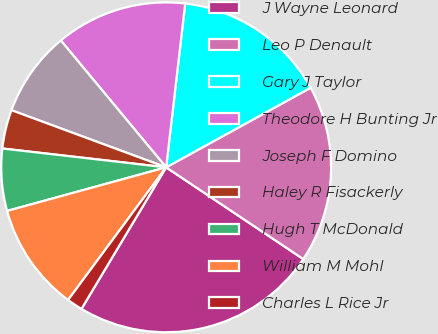<chart> <loc_0><loc_0><loc_500><loc_500><pie_chart><fcel>J Wayne Leonard<fcel>Leo P Denault<fcel>Gary J Taylor<fcel>Theodore H Bunting Jr<fcel>Joseph F Domino<fcel>Haley R Fisackerly<fcel>Hugh T McDonald<fcel>William M Mohl<fcel>Charles L Rice Jr<nl><fcel>24.2%<fcel>17.4%<fcel>15.14%<fcel>12.87%<fcel>8.34%<fcel>3.81%<fcel>6.08%<fcel>10.61%<fcel>1.55%<nl></chart> 